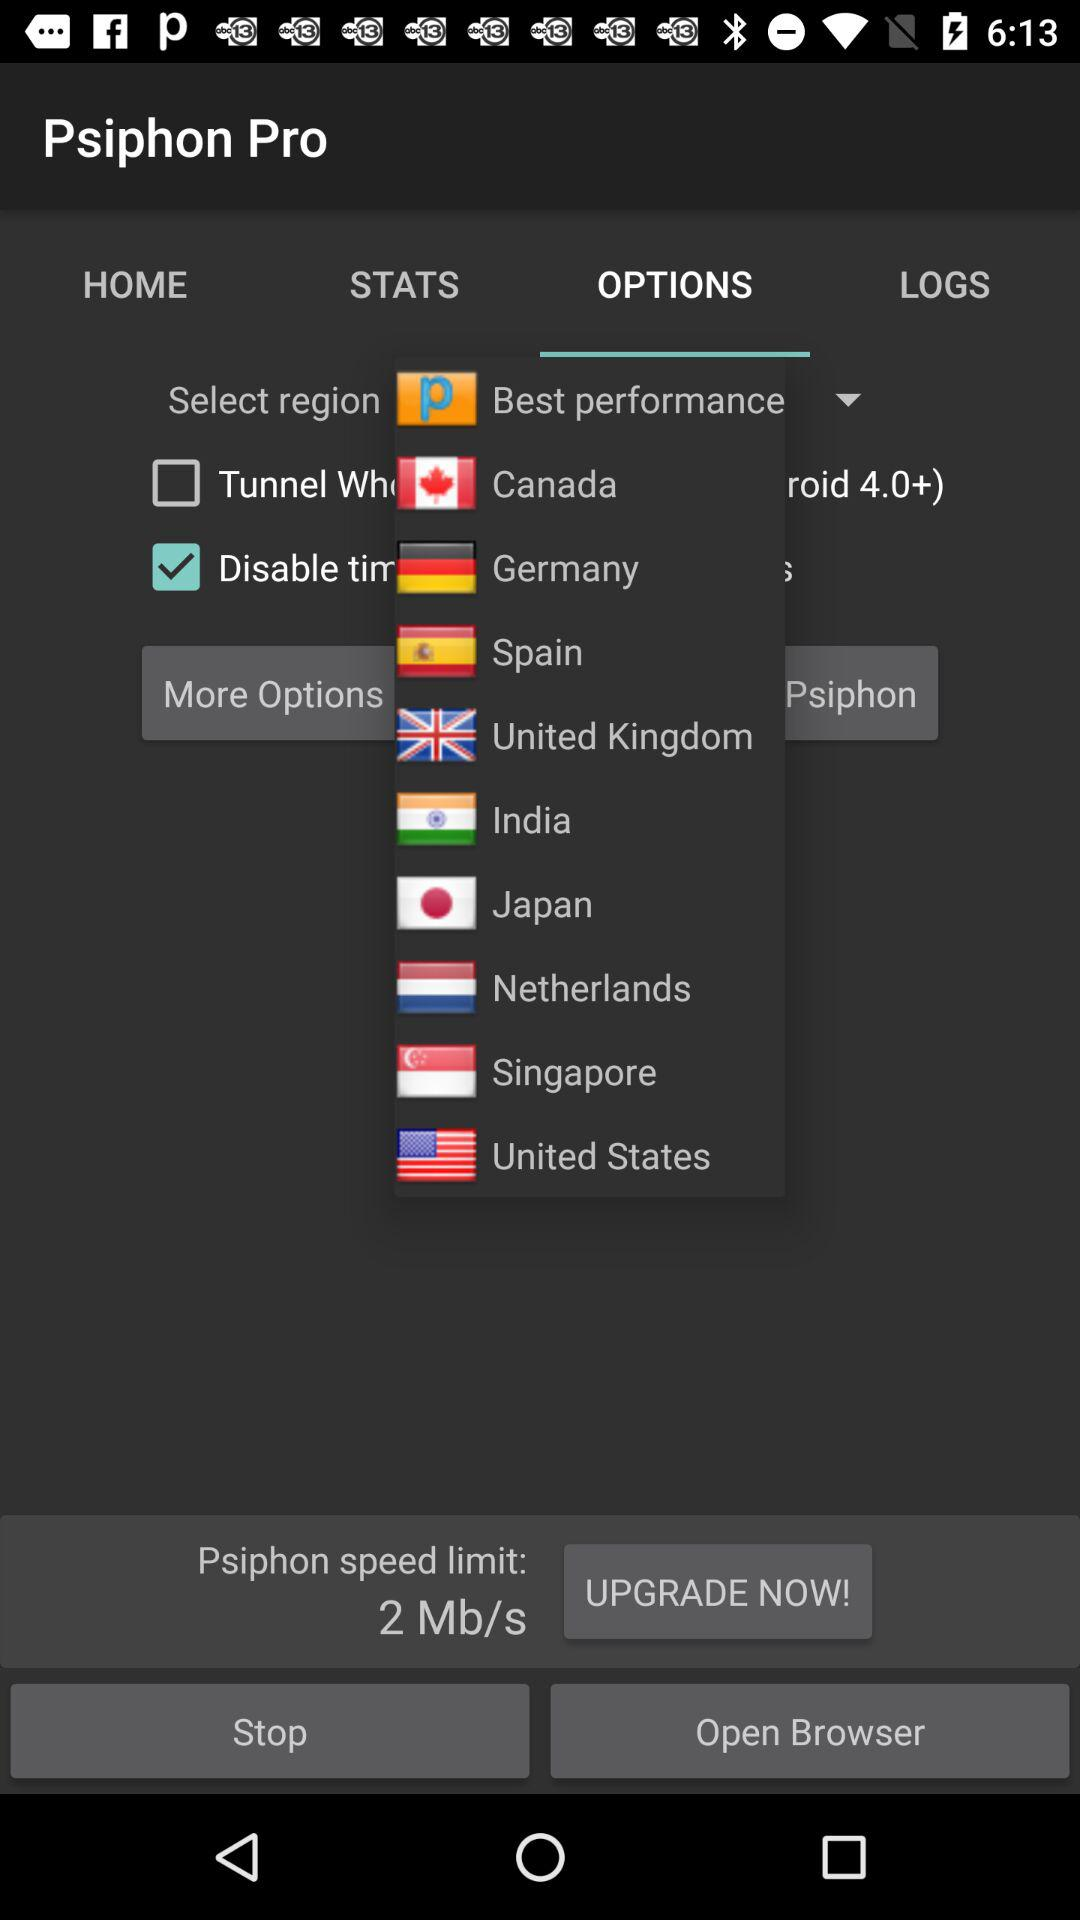What is the speed limit of the "Psiphon"? The speed limit of the "Psiphon" is 2 Mb/s. 